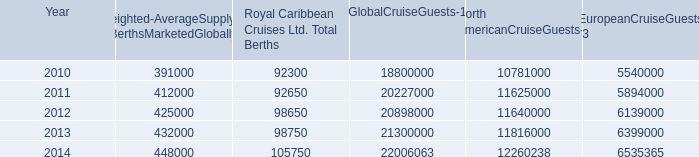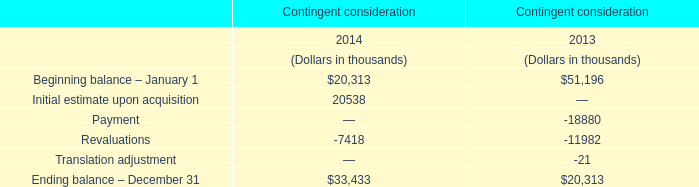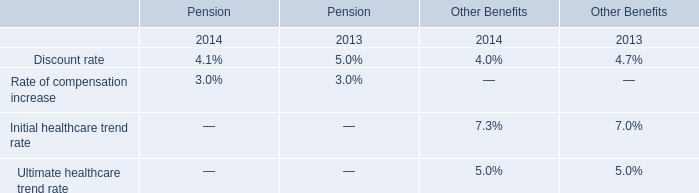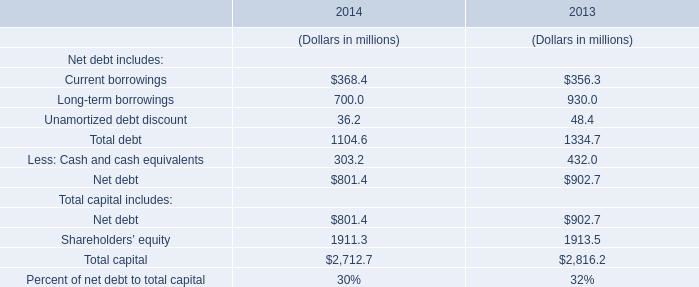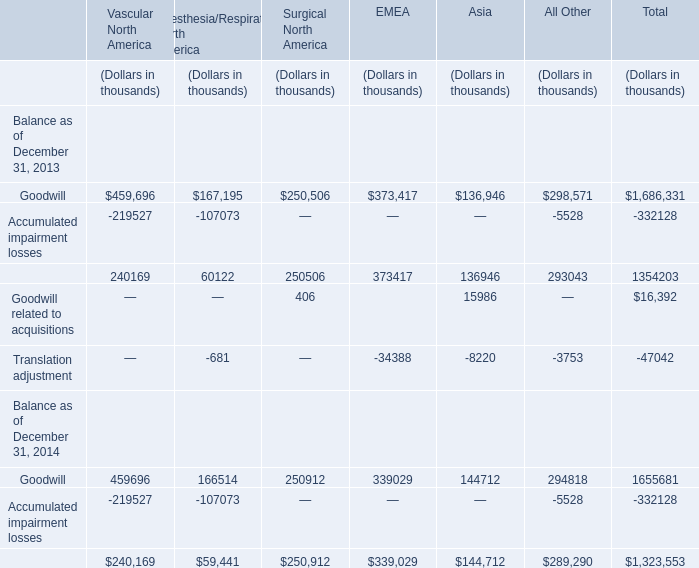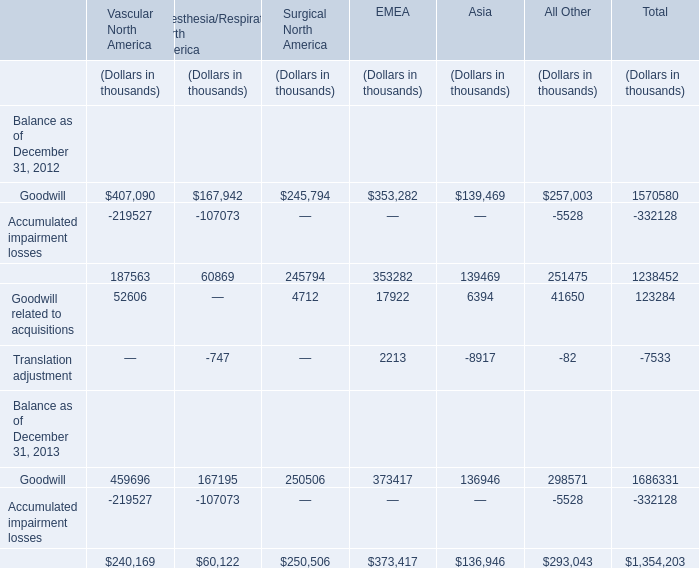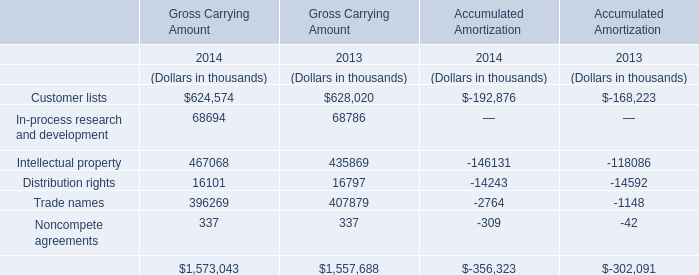What was the sum of Gross Carrying Amount without those elements smaller than 400000, in 2014? (in thousand) 
Computations: (624574 + 467068)
Answer: 1091642.0. 